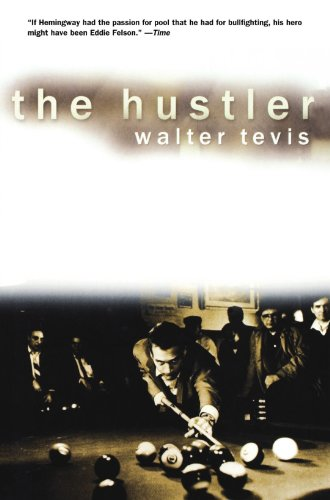Who is the author of this book? The author of the book depicted in the image is Walter Tevis, an American novelist well-known for his books about games, including 'The Hustler'. 